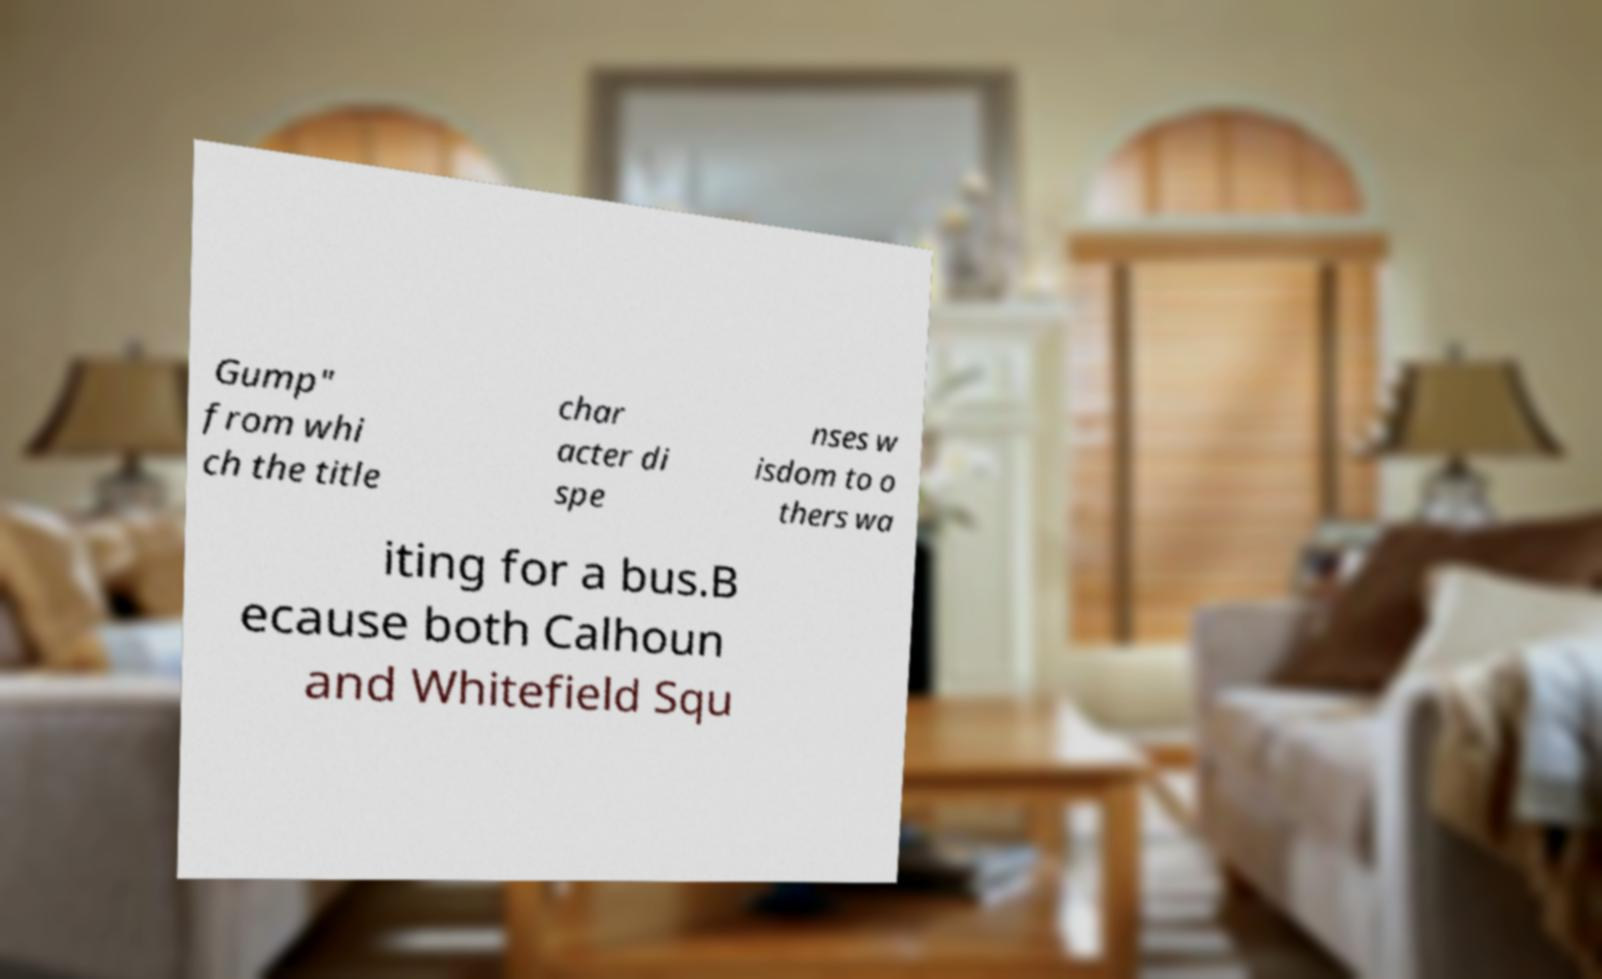Please read and relay the text visible in this image. What does it say? Gump" from whi ch the title char acter di spe nses w isdom to o thers wa iting for a bus.B ecause both Calhoun and Whitefield Squ 